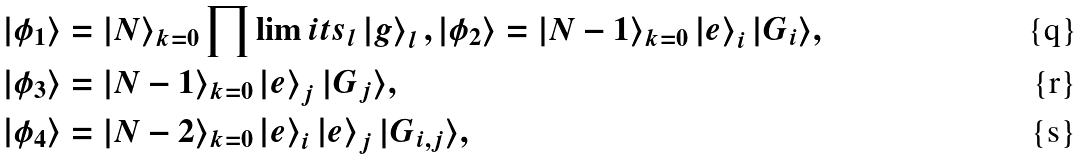<formula> <loc_0><loc_0><loc_500><loc_500>\left | \phi _ { 1 } \right \rangle & = | N \rangle _ { k = 0 } \prod \lim i t s _ { l } \left | g \right \rangle _ { l } , \left | \phi _ { 2 } \right \rangle = | N - 1 \rangle _ { k = 0 } \left | e \right \rangle _ { i } | G _ { i } \rangle , \\ \left | \phi _ { 3 } \right \rangle & = | N - 1 \rangle _ { k = 0 } \left | e \right \rangle _ { j } | G _ { j } \rangle , \\ \left | \phi _ { 4 } \right \rangle & = | N - 2 \rangle _ { k = 0 } \left | e \right \rangle _ { i } \left | e \right \rangle _ { j } | G _ { i , j } \rangle ,</formula> 